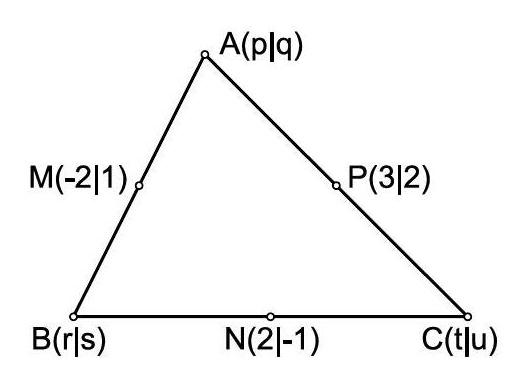The vertices of a triangle have the co-ordinates $A(p | q), B(r | s)$ and $C(t | u)$ as shown. The midpoints of the sides of the triangle are the points $\mathrm{M}(-2 | 1), \mathrm{N}(2 |-1)$ and $\mathrm{P}(3 | 2)$. Determine the value of the expression $p+q+r+s+t+u$ To determine the value of $p+q+r+s+t+u$, where $(p, q)$, $(r, s)$, and $(t, u)$ are the vertices of the triangle, and given the midpoints $(\mathrm{M}, \mathrm{N}, \mathrm{P})$ as $(-2, 1)$, $(2, -1)$, and $(3, 2)$ respectively, we first calculate the vertex coordinates using the midpoint formulas. For example, since point M is midpoint of $AB$, coordinates of $M$ are $(\frac{p+r}{2}, \frac{q+s}{2})$, and similar expressions hold for the other midpoints. Solving these equations gives the individual coordinates, and summing them results in 5. This careful calculation corroborates the solution and gives a more comprehensive understanding. 